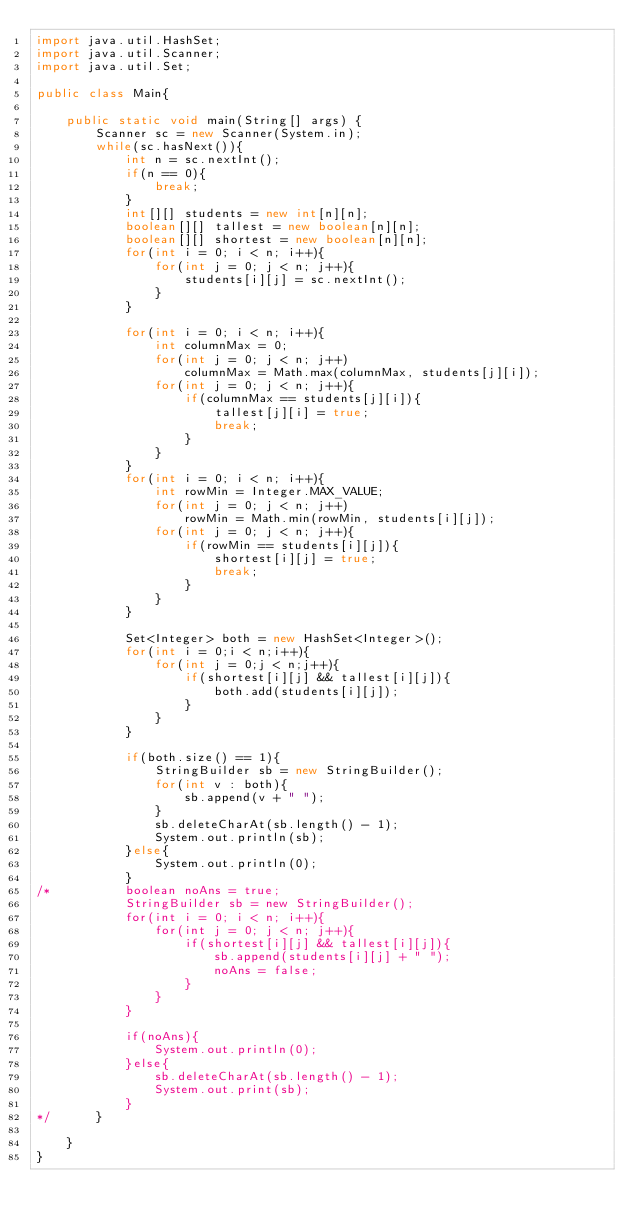<code> <loc_0><loc_0><loc_500><loc_500><_Java_>import java.util.HashSet;
import java.util.Scanner;
import java.util.Set;

public class Main{

	public static void main(String[] args) {
		Scanner sc = new Scanner(System.in);
		while(sc.hasNext()){
			int n = sc.nextInt();
			if(n == 0){
				break;
			}
			int[][] students = new int[n][n];
			boolean[][] tallest = new boolean[n][n];
			boolean[][] shortest = new boolean[n][n];
			for(int i = 0; i < n; i++){
				for(int j = 0; j < n; j++){
					students[i][j] = sc.nextInt();
				}
			}
			
			for(int i = 0; i < n; i++){
				int columnMax = 0;
				for(int j = 0; j < n; j++)
					columnMax = Math.max(columnMax, students[j][i]);
				for(int j = 0; j < n; j++){
					if(columnMax == students[j][i]){
						tallest[j][i] = true;
						break;
					}
				}
			}
			for(int i = 0; i < n; i++){
				int rowMin = Integer.MAX_VALUE;
				for(int j = 0; j < n; j++)
					rowMin = Math.min(rowMin, students[i][j]);
				for(int j = 0; j < n; j++){
					if(rowMin == students[i][j]){
						shortest[i][j] = true;
						break;
					}
				}
			}
			
			Set<Integer> both = new HashSet<Integer>();
            for(int i = 0;i < n;i++){
                for(int j = 0;j < n;j++){
                    if(shortest[i][j] && tallest[i][j]){
                        both.add(students[i][j]);
                    }
                }
            }
			
            if(both.size() == 1){
            	StringBuilder sb = new StringBuilder();
                for(int v : both){
                    sb.append(v + " ");
                }
                sb.deleteCharAt(sb.length() - 1);
                System.out.println(sb);
            }else{
            	System.out.println(0);
            }
/*			boolean noAns = true;
			StringBuilder sb = new StringBuilder();
			for(int i = 0; i < n; i++){
				for(int j = 0; j < n; j++){
					if(shortest[i][j] && tallest[i][j]){
						sb.append(students[i][j] + " ");
						noAns = false;
					}
				}
			}
			
			if(noAns){
				System.out.println(0);
			}else{
				sb.deleteCharAt(sb.length() - 1);
				System.out.print(sb);
			}
*/		}
		
	}
}</code> 